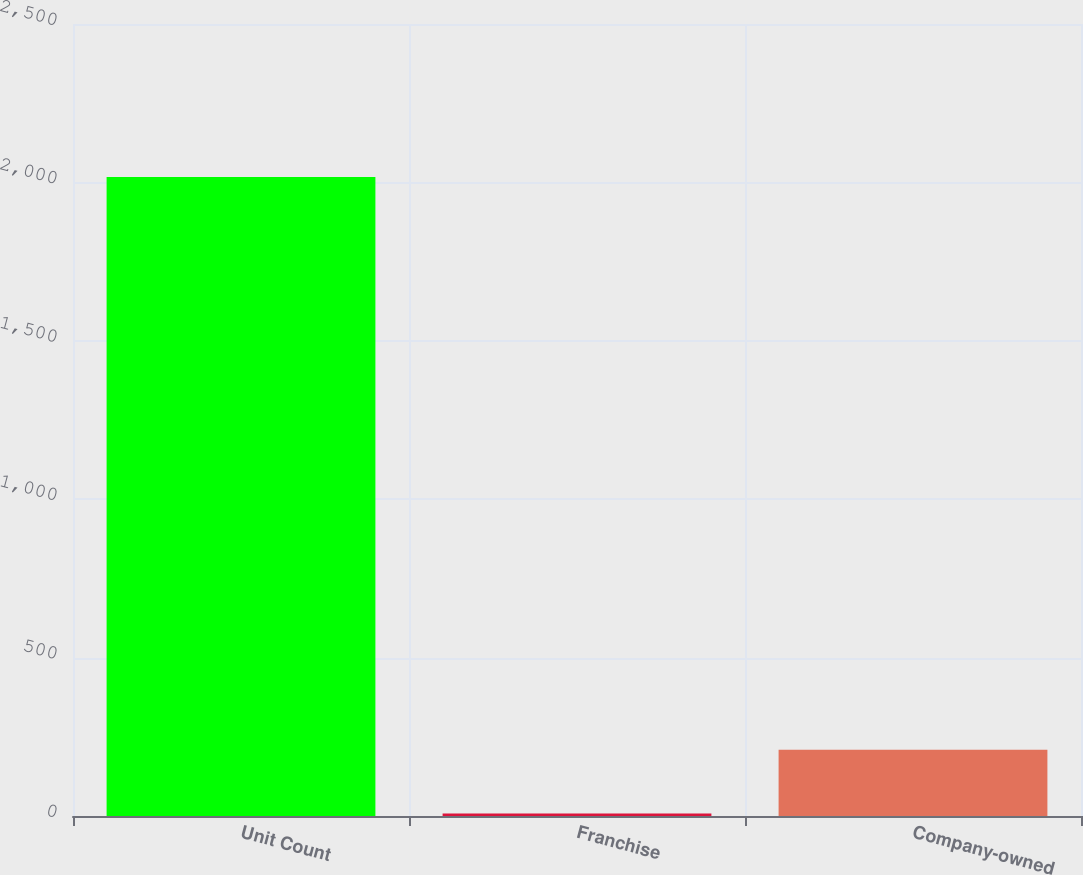<chart> <loc_0><loc_0><loc_500><loc_500><bar_chart><fcel>Unit Count<fcel>Franchise<fcel>Company-owned<nl><fcel>2017<fcel>8<fcel>208.9<nl></chart> 